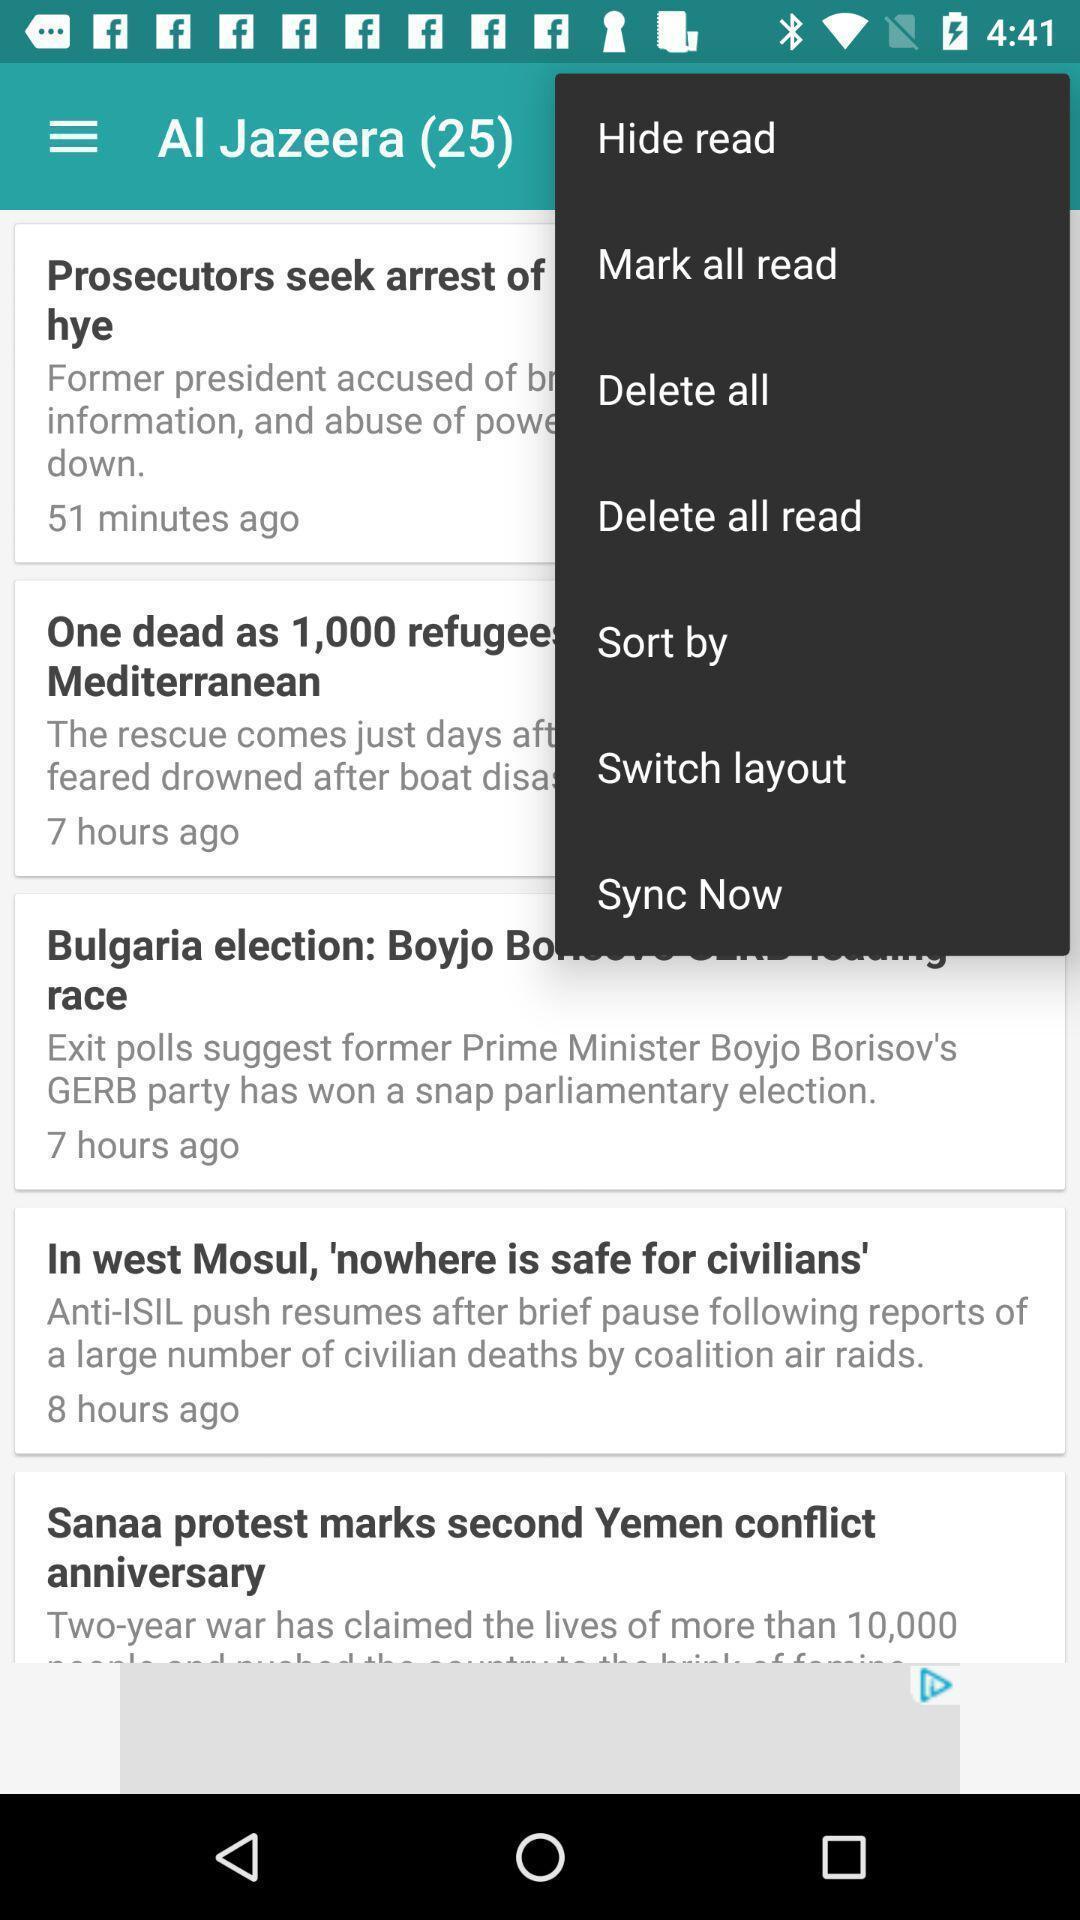Describe the content in this image. Screen about list of news articles. 